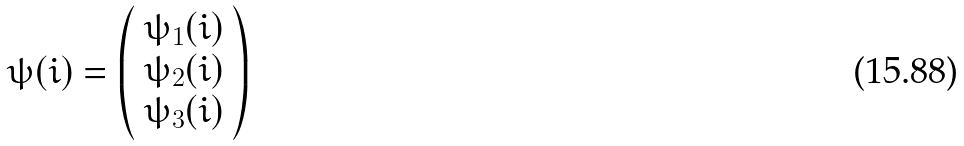Convert formula to latex. <formula><loc_0><loc_0><loc_500><loc_500>\psi ( i ) = \left ( \begin{array} { c } \psi _ { 1 } ( i ) \\ \psi _ { 2 } ( i ) \\ \psi _ { 3 } ( i ) \end{array} \right )</formula> 